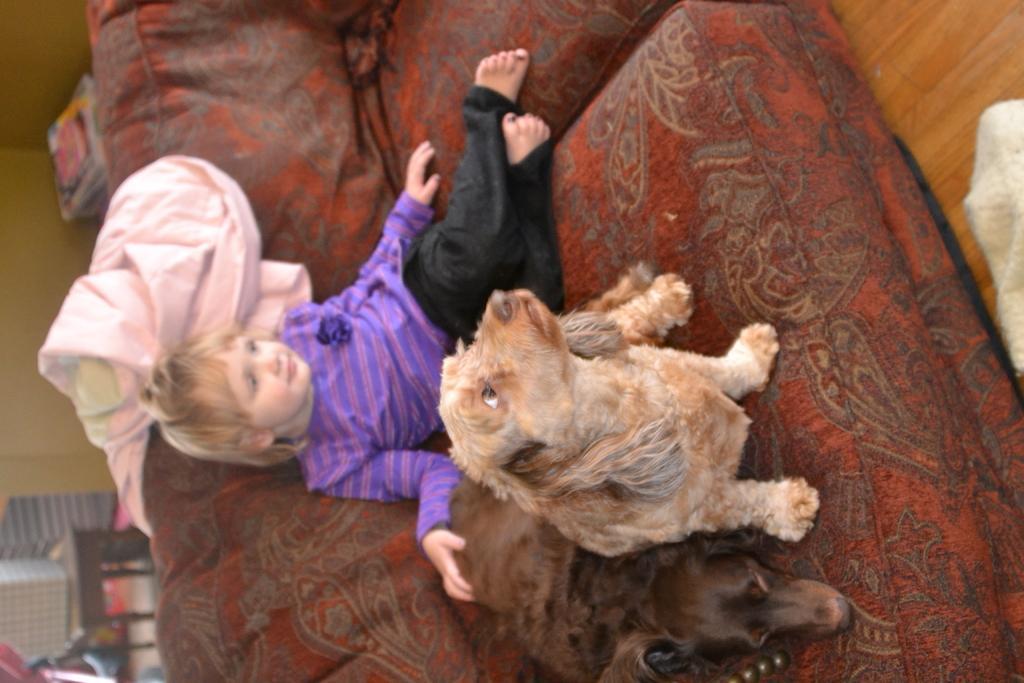How would you summarize this image in a sentence or two? As we can see in the image there is a cloth, a girl and two dogs on sofa. 